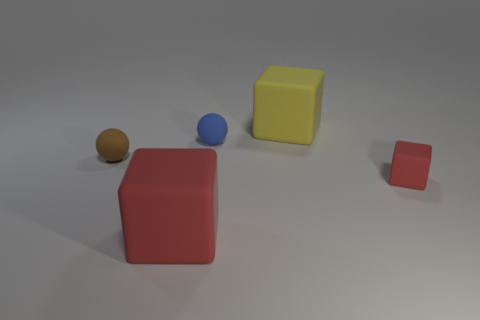Subtract all red blocks. How many blocks are left? 1 Add 1 brown rubber spheres. How many objects exist? 6 Subtract all blue balls. How many balls are left? 1 Subtract all cyan cubes. Subtract all brown balls. How many cubes are left? 3 Subtract all purple blocks. How many brown balls are left? 1 Subtract all yellow rubber cubes. Subtract all tiny metallic cylinders. How many objects are left? 4 Add 5 spheres. How many spheres are left? 7 Add 4 big yellow rubber objects. How many big yellow rubber objects exist? 5 Subtract 0 purple cylinders. How many objects are left? 5 Subtract all spheres. How many objects are left? 3 